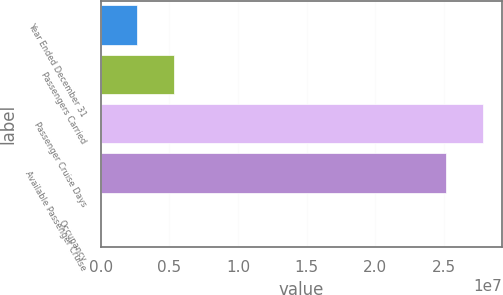<chart> <loc_0><loc_0><loc_500><loc_500><bar_chart><fcel>Year Ended December 31<fcel>Passengers Carried<fcel>Passenger Cruise Days<fcel>Available Passenger Cruise<fcel>Occupancy<nl><fcel>2.65955e+06<fcel>5.31899e+06<fcel>2.78152e+07<fcel>2.51558e+07<fcel>105.7<nl></chart> 